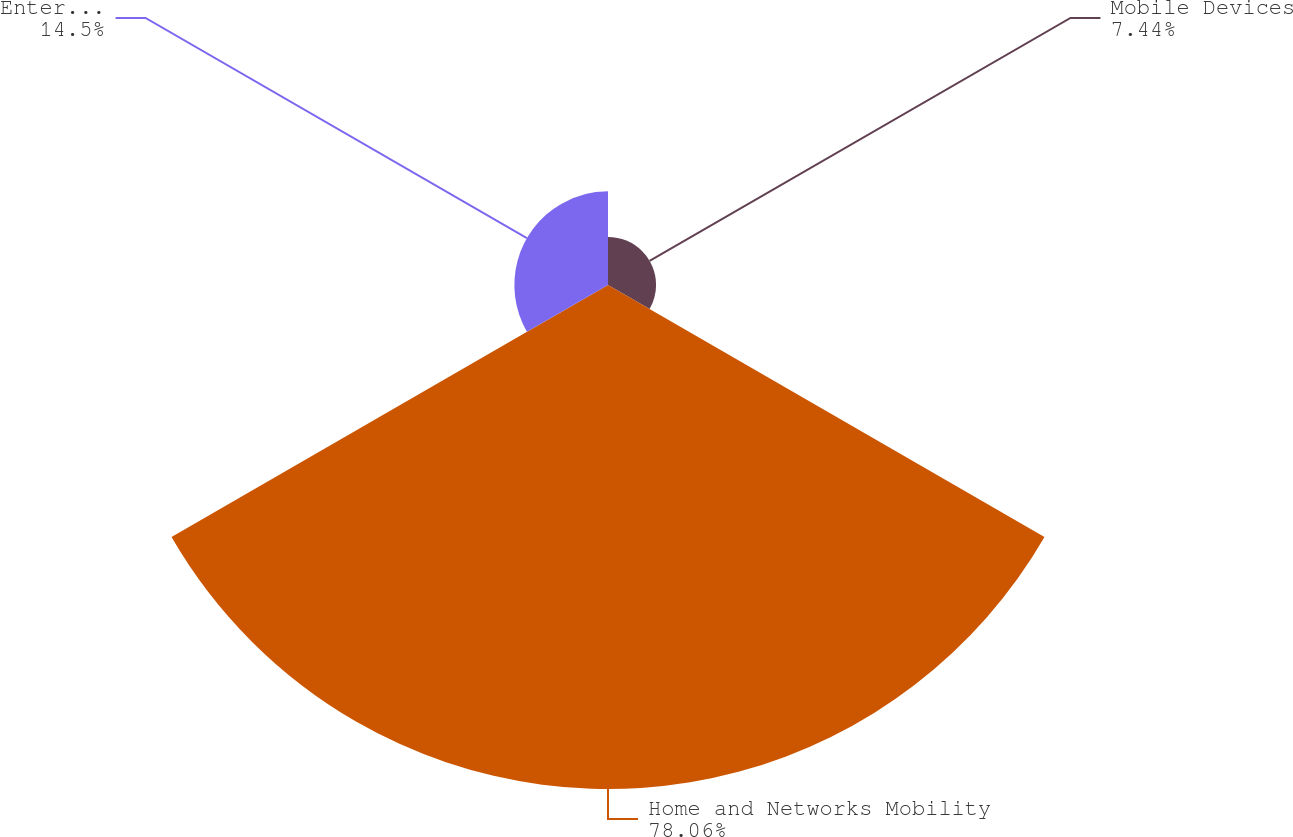Convert chart. <chart><loc_0><loc_0><loc_500><loc_500><pie_chart><fcel>Mobile Devices<fcel>Home and Networks Mobility<fcel>Enterprise Mobility Solutions<nl><fcel>7.44%<fcel>78.05%<fcel>14.5%<nl></chart> 